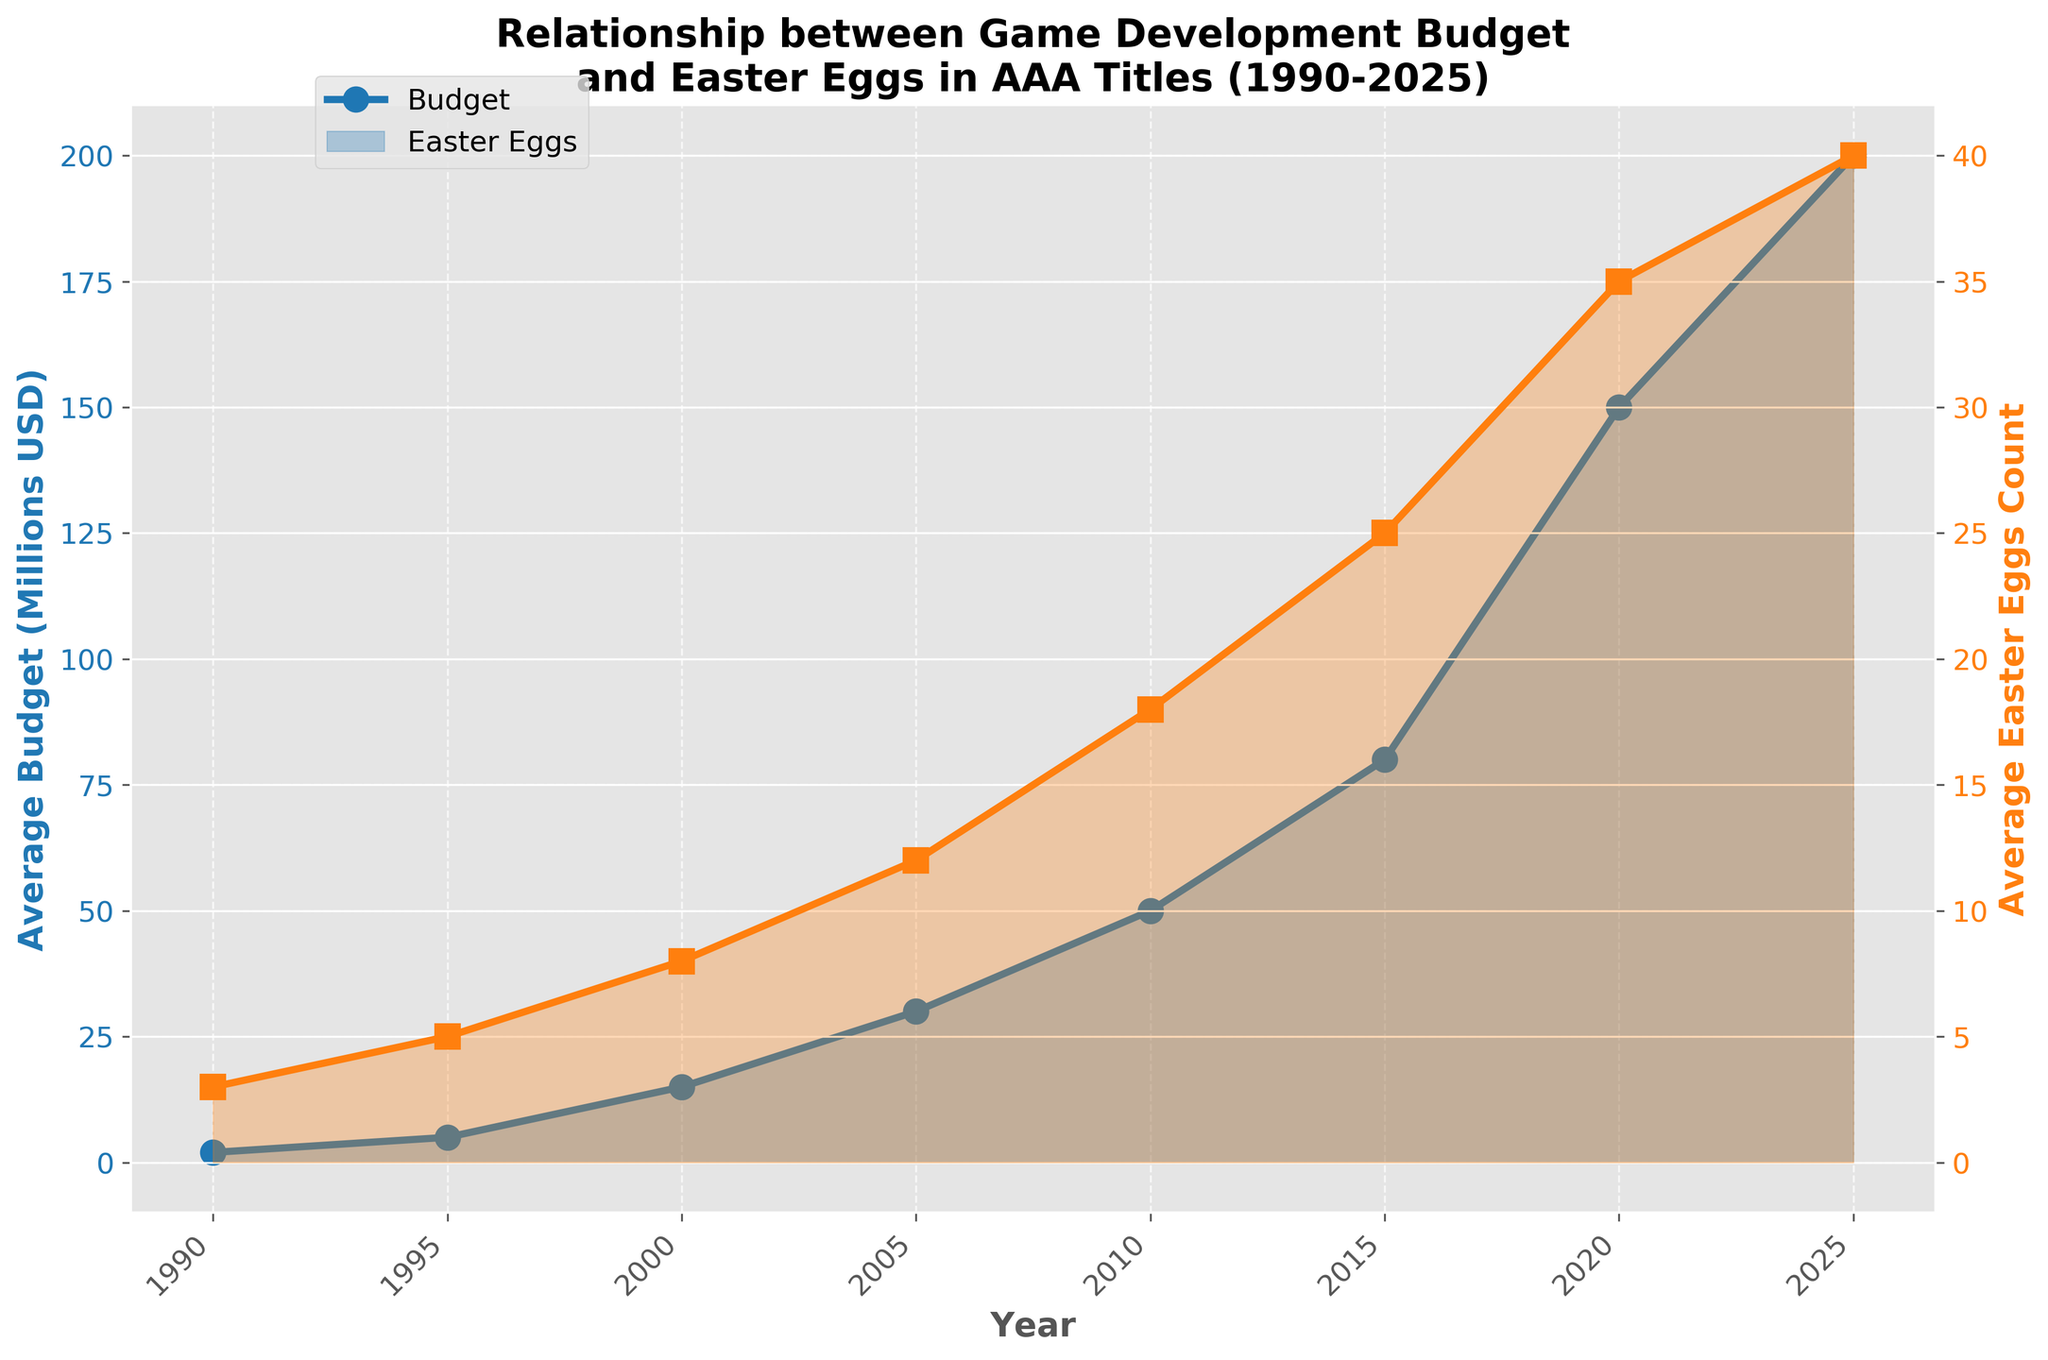What's the highest average budget observed over the years? The highest average budget can be observed in the rightmost (or most recent) data point on the blue line representing budgets.
Answer: 200 (Millions USD) How has the average number of easter eggs changed from 1990 to 2025? To determine this, look at the first (leftmost) and last (rightmost) data points on the orange line representing the average number of Easter eggs. In 1990, the count was 3, and in 2025, it's 40.
Answer: Increased by 37 Which year saw the most significant increase in average budget compared to the previous year? Calculate the differences between consecutive years for the blue line representing budgets, and find the largest increase. The biggest leap is between 2015 ($80M) and 2020 ($150M), which is an increase of $70M.
Answer: 2020 Is the growth rate of the average Easter eggs count faster than the growth rate of the average budget? Comparing the slopes or rate of change for both lines, the growth of the average Easter eggs count appears to be consistently increasing and has a similar growth rate to the budget. However, for precision, comparing the ratio of the final to initial value for both datasets would help. Budget grew 100x (from 2 to 200), while Easter eggs grew ~13.3x (from 3 to 40), meaning budget grew faster.
Answer: No Between 2010 and 2015, which had a more significant proportional increase: budget or Easter eggs count? Compare the percentage increase between 2010 and 2015 for both metrics. Budget went from $50M to $80M, an increase of 60%. Easter eggs count went from 18 to 25, an increase of 38.9%.
Answer: Budget In what year did the average Easter eggs count first double from its 1990 value? The 1990 value is 3. Doubling this gives 6. Looking at the orange line, it crossed 6 between 2000 (8 Easter eggs) and 1995 (5 Easter eggs). Thus, the answer is 2000.
Answer: 2000 What's the average growth in the number of Easter eggs per decade? From 1990 (3) to 2025 (40), the total period is 35 years. Calculate the total increase (40-3=37) and then divide by the number of decades in the period (3.5 decades). 37/3.5 = 10.57.
Answer: Approximately 10.57 How many more Easter eggs were there on average in 2025 compared to 2010? Look at the data points for 2025 and 2010 on the orange line. 2025: 40, 2010: 18. The difference is 40 - 18 = 22.
Answer: 22 Between which consecutive years did the average number of Easter eggs see the smallest increase? Analyze the differences between consecutive years for the orange line representing Easter eggs. The smallest increase is between 2020 (35) and 2025 (40), an increase of just 5.
Answer: 2020 and 2025 When did the average budget cross the 100 million USD mark? Observe the blue line to identify the year when the average budget first exceeded 100 million USD. This happens at 2020 (150 million USD).
Answer: 2020 